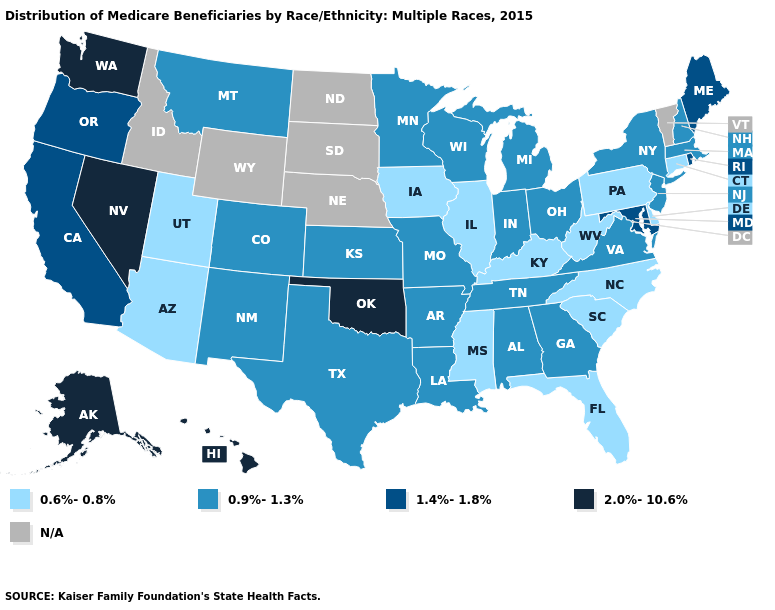Name the states that have a value in the range 1.4%-1.8%?
Answer briefly. California, Maine, Maryland, Oregon, Rhode Island. What is the value of Montana?
Keep it brief. 0.9%-1.3%. What is the value of Kentucky?
Short answer required. 0.6%-0.8%. What is the lowest value in the USA?
Keep it brief. 0.6%-0.8%. Name the states that have a value in the range 0.6%-0.8%?
Answer briefly. Arizona, Connecticut, Delaware, Florida, Illinois, Iowa, Kentucky, Mississippi, North Carolina, Pennsylvania, South Carolina, Utah, West Virginia. Name the states that have a value in the range 0.6%-0.8%?
Give a very brief answer. Arizona, Connecticut, Delaware, Florida, Illinois, Iowa, Kentucky, Mississippi, North Carolina, Pennsylvania, South Carolina, Utah, West Virginia. What is the lowest value in the MidWest?
Quick response, please. 0.6%-0.8%. Name the states that have a value in the range 0.9%-1.3%?
Keep it brief. Alabama, Arkansas, Colorado, Georgia, Indiana, Kansas, Louisiana, Massachusetts, Michigan, Minnesota, Missouri, Montana, New Hampshire, New Jersey, New Mexico, New York, Ohio, Tennessee, Texas, Virginia, Wisconsin. How many symbols are there in the legend?
Quick response, please. 5. Among the states that border Wyoming , does Colorado have the lowest value?
Keep it brief. No. Does Delaware have the lowest value in the South?
Short answer required. Yes. What is the lowest value in the MidWest?
Give a very brief answer. 0.6%-0.8%. Which states have the lowest value in the USA?
Keep it brief. Arizona, Connecticut, Delaware, Florida, Illinois, Iowa, Kentucky, Mississippi, North Carolina, Pennsylvania, South Carolina, Utah, West Virginia. Which states hav the highest value in the West?
Answer briefly. Alaska, Hawaii, Nevada, Washington. What is the lowest value in the Northeast?
Quick response, please. 0.6%-0.8%. 